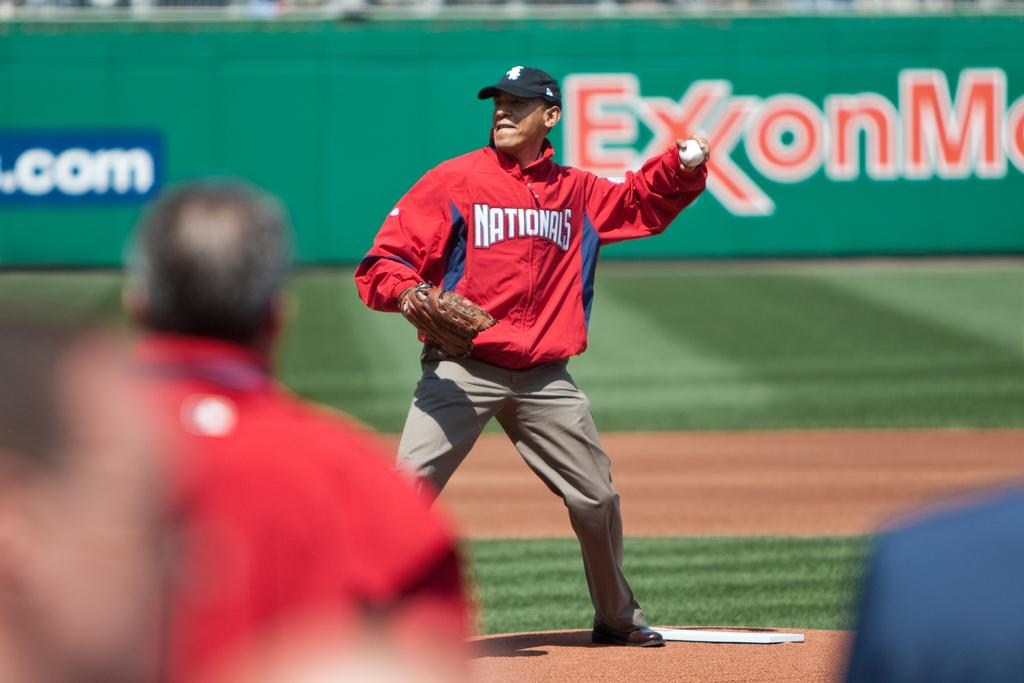Provide a one-sentence caption for the provided image. A man wearing a Nationals jacket and khaki pants standing an the pitchers mound and throwing a baseball. 